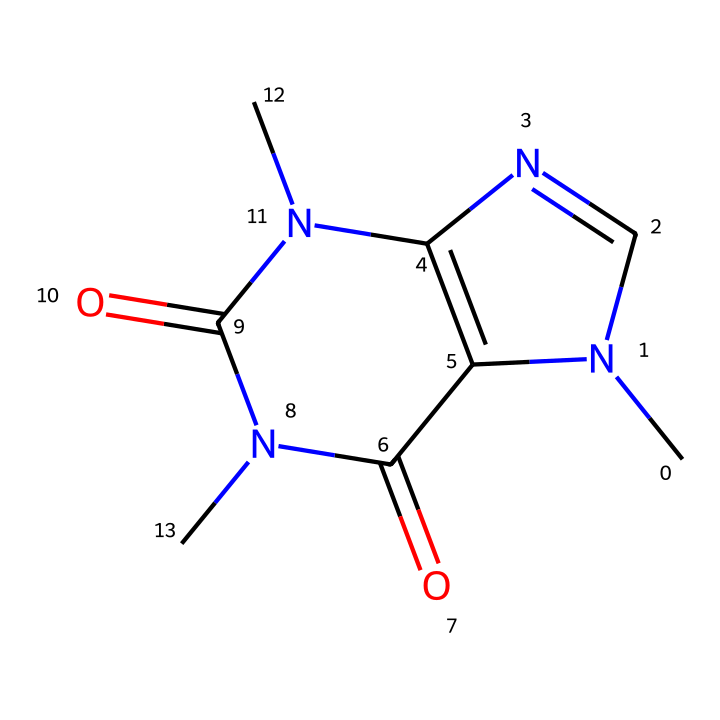What is the molecular formula of caffeine? By examining the SMILES representation, we can identify the various atoms present. The chemical consists of 8 carbon atoms (C), 10 hydrogen atoms (H), 4 nitrogen atoms (N), and 2 oxygen atoms (O). This gives us the molecular formula C8H10N4O2.
Answer: C8H10N4O2 How many nitrogen atoms are in this structure? The SMILES indicates the presence of nitrogen atoms represented by "N". By counting the "N" symbols, we see that there are 4 nitrogen atoms in total.
Answer: 4 What type of compound is caffeine classified as? Caffeine is classified in the category of alkaloids, which are compounds that are typically composed of basic nitrogen-containing ring structures. The presence of its nitrogen rings (cage-like) confirms it is an alkaloid.
Answer: alkaloid What effect does caffeine have on alertness? Caffeine acts as a stimulant, primarily by blocking adenosine receptors, which reduces feelings of tiredness and increases alertness. This is a known physiological effect of caffeine consumption.
Answer: stimulant Is caffeine soluble in water? Due to the presence of polar functional groups, such as nitrogen and carbonyl groups, caffeine is relatively soluble in water, which facilitates its absorption in biological systems.
Answer: yes What kind of structural feature does caffeine have that characterizes it as a cage compound? The 'cage' nature of caffeine arises from its fused ring structure that comprises two rings connected, creating a more complex framework that qualifies it for the cage classification.
Answer: fused rings 